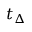<formula> <loc_0><loc_0><loc_500><loc_500>t _ { \Delta }</formula> 